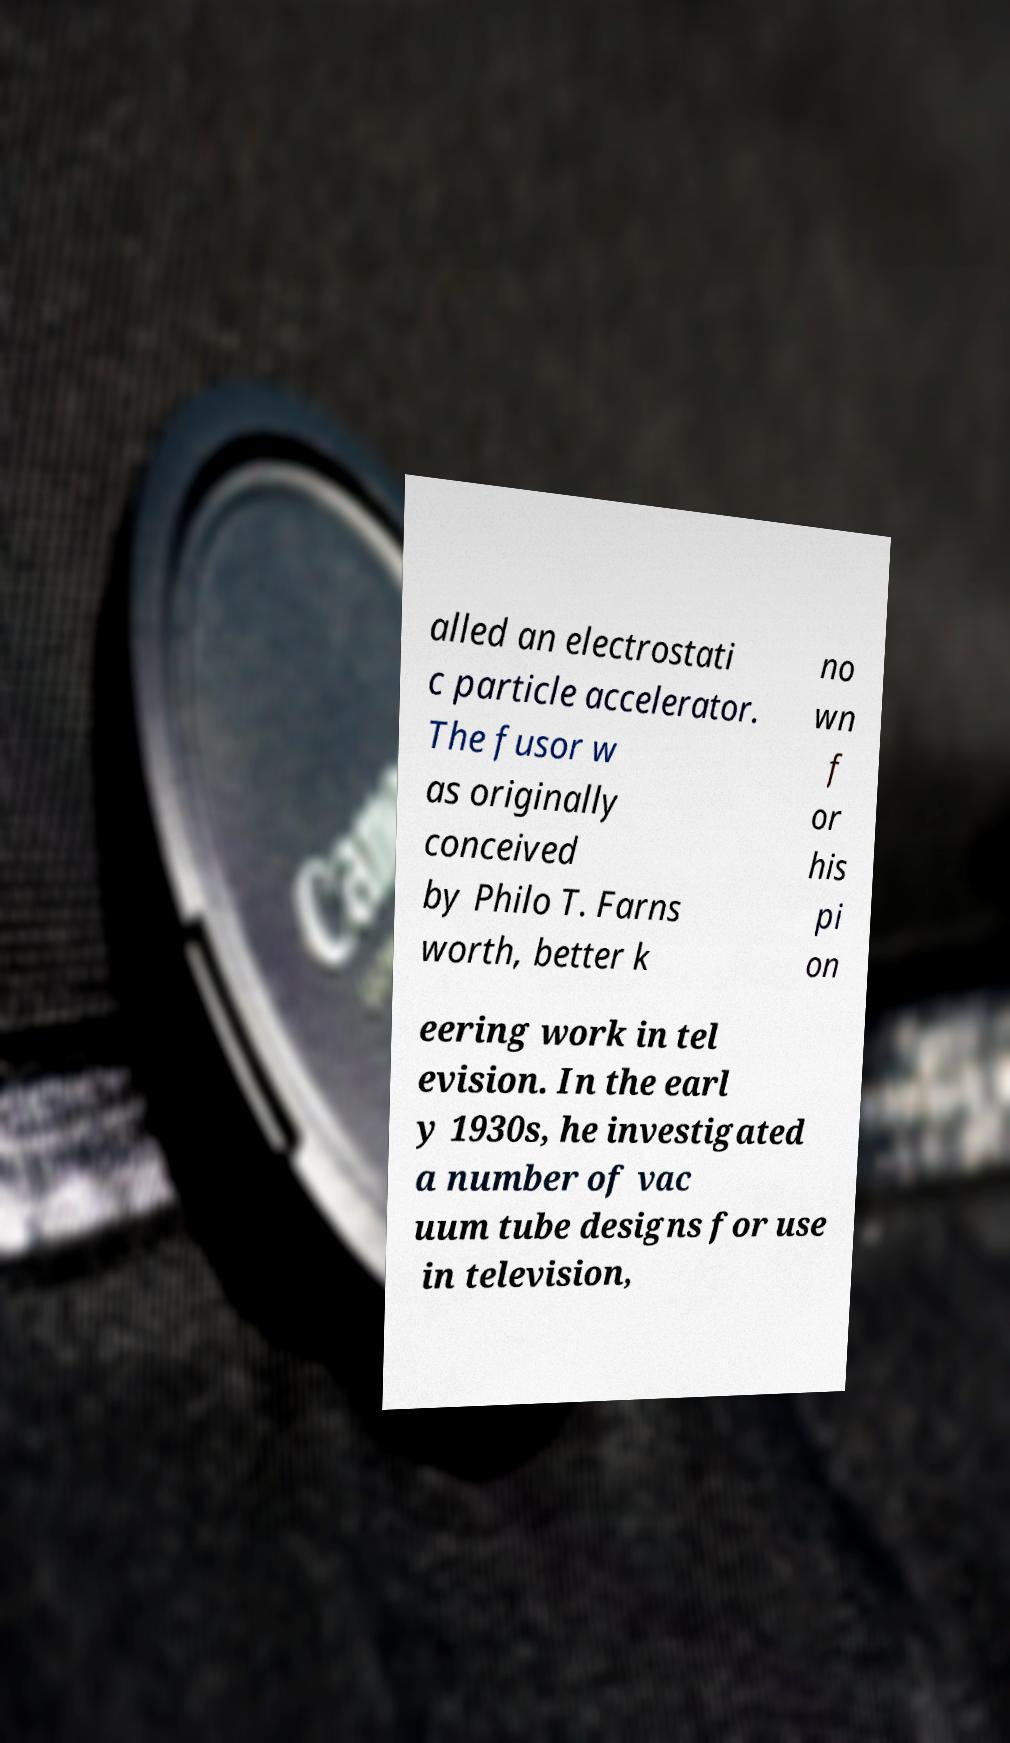Could you assist in decoding the text presented in this image and type it out clearly? alled an electrostati c particle accelerator. The fusor w as originally conceived by Philo T. Farns worth, better k no wn f or his pi on eering work in tel evision. In the earl y 1930s, he investigated a number of vac uum tube designs for use in television, 